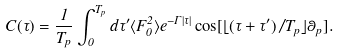<formula> <loc_0><loc_0><loc_500><loc_500>C ( \tau ) = \frac { 1 } { T _ { p } } \int _ { 0 } ^ { T _ { p } } d \tau ^ { \prime } \langle F _ { 0 } ^ { 2 } \rangle e ^ { - \Gamma | \tau | } \cos [ \lfloor ( \tau + \tau ^ { \prime } ) / T _ { p } \rfloor \theta _ { p } ] .</formula> 